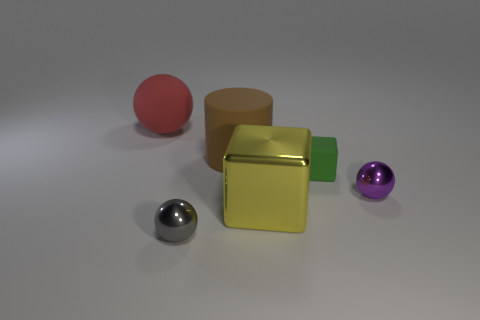There is a metal sphere that is to the left of the green matte cube; is it the same color as the tiny matte object?
Ensure brevity in your answer.  No. The red object that is the same shape as the tiny gray metallic object is what size?
Offer a terse response. Large. Are there any other things that have the same size as the gray metallic ball?
Provide a succinct answer. Yes. There is a tiny sphere that is to the left of the tiny sphere behind the tiny thing in front of the tiny purple object; what is it made of?
Offer a terse response. Metal. Is the number of big red balls to the right of the small gray metallic ball greater than the number of purple metal spheres right of the purple metallic thing?
Give a very brief answer. No. Is the size of the rubber cube the same as the purple shiny sphere?
Keep it short and to the point. Yes. There is another rubber thing that is the same shape as the big yellow object; what color is it?
Your answer should be compact. Green. What number of small balls have the same color as the large cylinder?
Your answer should be compact. 0. Are there more big brown matte cylinders left of the red object than small green objects?
Your answer should be very brief. No. There is a shiny ball that is right of the block behind the tiny purple object; what is its color?
Your answer should be very brief. Purple. 